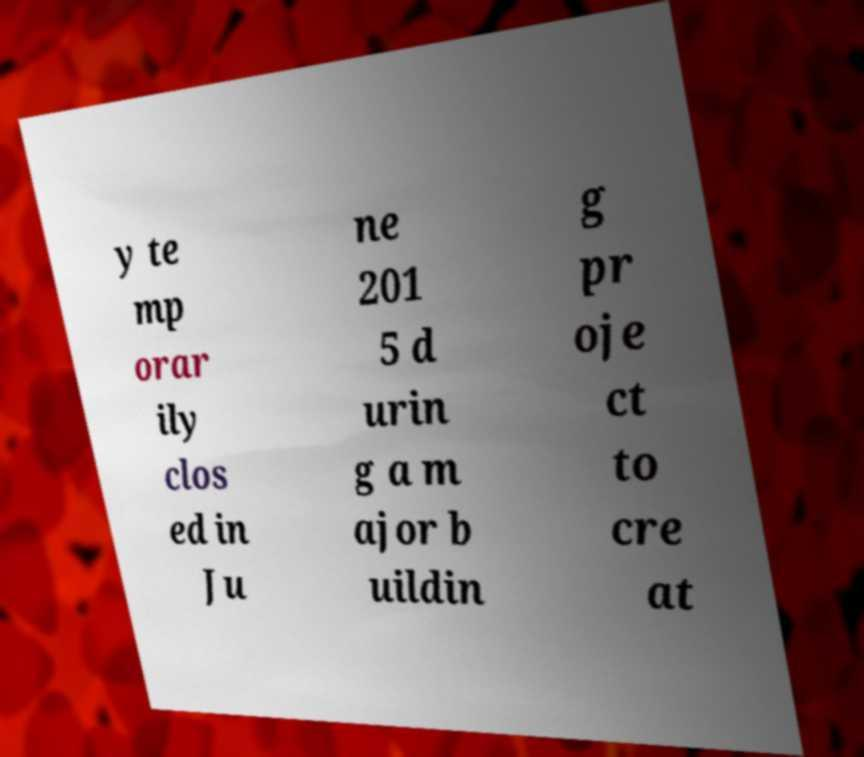Could you extract and type out the text from this image? y te mp orar ily clos ed in Ju ne 201 5 d urin g a m ajor b uildin g pr oje ct to cre at 